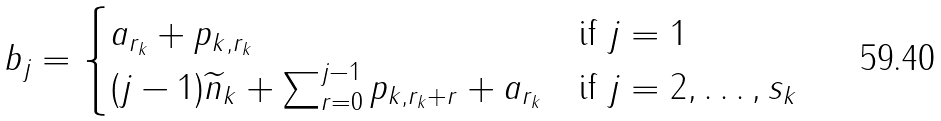Convert formula to latex. <formula><loc_0><loc_0><loc_500><loc_500>b _ { j } = \begin{cases} a _ { r _ { k } } + p _ { k , r _ { k } } & \text {if $j=1$} \\ ( j - 1 ) \widetilde { n } _ { k } + \sum _ { r = 0 } ^ { j - 1 } p _ { k , r _ { k } + r } + a _ { r _ { k } } & \text {if $j= 2, \dots , s_{k} $} \end{cases}</formula> 